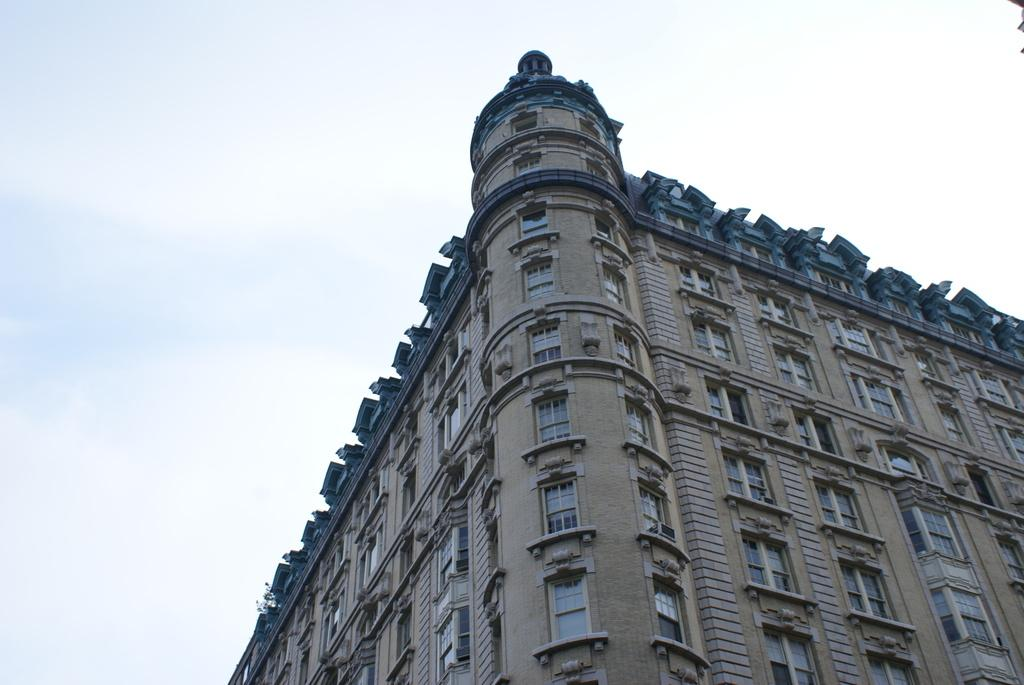What is the main subject of the image? The main subject of the image is a building. Can you describe the building in more detail? The building has multiple windows. What can be seen in the background of the image? The sky is visible in the background of the image. What type of neck accessory is the building wearing in the image? There is no neck accessory present in the image, as the subject is a building. 